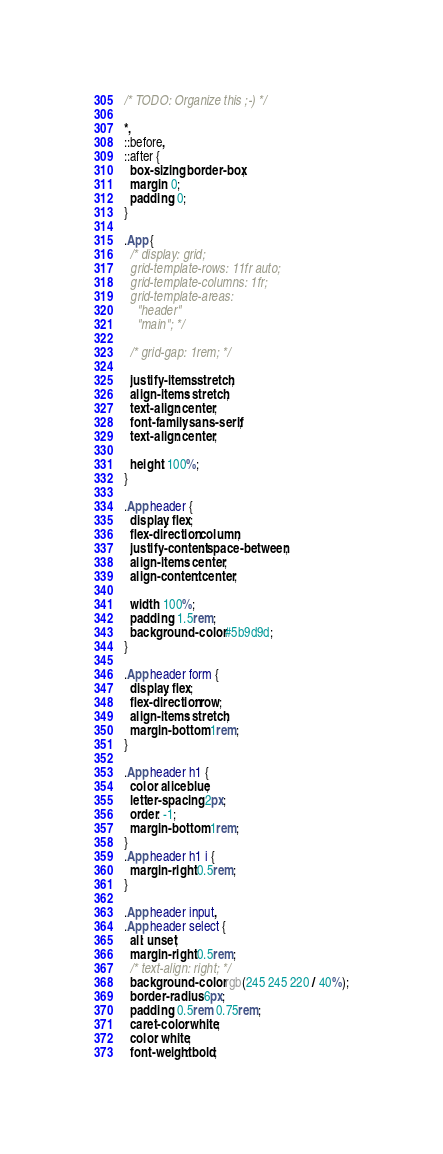<code> <loc_0><loc_0><loc_500><loc_500><_CSS_>/* TODO: Organize this ;-) */

*,
::before,
::after {
  box-sizing: border-box;
  margin: 0;
  padding: 0;
}

.App {
  /* display: grid;
  grid-template-rows: 11fr auto;
  grid-template-columns: 1fr;
  grid-template-areas:
    "header"
    "main"; */

  /* grid-gap: 1rem; */

  justify-items: stretch;
  align-items: stretch;
  text-align: center;
  font-family: sans-serif;
  text-align: center;

  height: 100%;
}

.App header {
  display: flex;
  flex-direction: column;
  justify-content: space-between;
  align-items: center;
  align-content: center;

  width: 100%;
  padding: 1.5rem;
  background-color: #5b9d9d;
}

.App header form {
  display: flex;
  flex-direction: row;
  align-items: stretch;
  margin-bottom: 1rem;
}

.App header h1 {
  color: aliceblue;
  letter-spacing: 2px;
  order: -1;
  margin-bottom: 1rem;
}
.App header h1 i {
  margin-right: 0.5rem;
}

.App header input,
.App header select {
  all: unset;
  margin-right: 0.5rem;
  /* text-align: right; */
  background-color: rgb(245 245 220 / 40%);
  border-radius: 6px;
  padding: 0.5rem 0.75rem;
  caret-color: white;
  color: white;
  font-weight: bold;</code> 